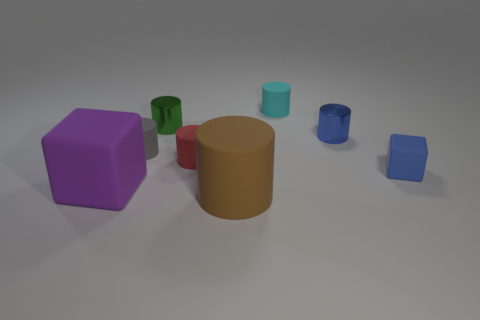What is the brown cylinder made of?
Provide a succinct answer. Rubber. How many other things are there of the same material as the small blue cylinder?
Offer a terse response. 1. There is a rubber thing that is to the right of the brown cylinder and in front of the blue cylinder; how big is it?
Provide a succinct answer. Small. There is a tiny blue object to the left of the matte block to the right of the brown matte thing; what is its shape?
Your answer should be very brief. Cylinder. Is there anything else that has the same shape as the gray rubber thing?
Ensure brevity in your answer.  Yes. Are there the same number of tiny matte things in front of the red cylinder and small rubber cylinders?
Keep it short and to the point. No. There is a large cylinder; does it have the same color as the object that is left of the small gray matte thing?
Make the answer very short. No. There is a tiny cylinder that is both to the left of the brown rubber cylinder and behind the small gray object; what is its color?
Give a very brief answer. Green. How many small rubber cubes are left of the tiny shiny cylinder that is left of the brown object?
Your response must be concise. 0. Is there a big green thing that has the same shape as the red matte thing?
Your answer should be very brief. No. 